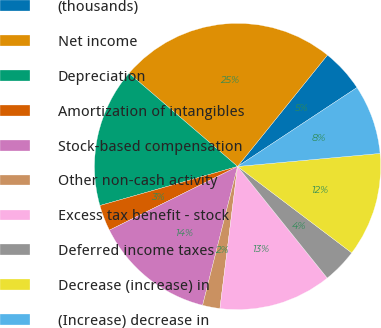Convert chart. <chart><loc_0><loc_0><loc_500><loc_500><pie_chart><fcel>(thousands)<fcel>Net income<fcel>Depreciation<fcel>Amortization of intangibles<fcel>Stock-based compensation<fcel>Other non-cash activity<fcel>Excess tax benefit - stock<fcel>Deferred income taxes<fcel>Decrease (increase) in<fcel>(Increase) decrease in<nl><fcel>4.9%<fcel>24.51%<fcel>15.69%<fcel>2.94%<fcel>13.73%<fcel>1.96%<fcel>12.74%<fcel>3.92%<fcel>11.76%<fcel>7.84%<nl></chart> 